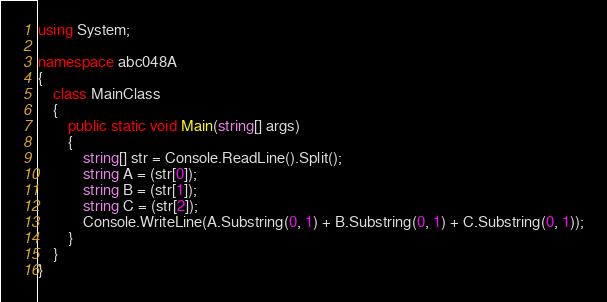Convert code to text. <code><loc_0><loc_0><loc_500><loc_500><_C#_>using System;

namespace abc048A
{
    class MainClass
    {
        public static void Main(string[] args)
        {
            string[] str = Console.ReadLine().Split();
            string A = (str[0]);
            string B = (str[1]);
            string C = (str[2]);
            Console.WriteLine(A.Substring(0, 1) + B.Substring(0, 1) + C.Substring(0, 1));
        }
    }
}
</code> 